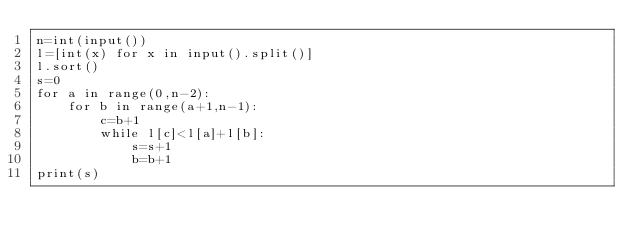Convert code to text. <code><loc_0><loc_0><loc_500><loc_500><_Python_>n=int(input())
l=[int(x) for x in input().split()]
l.sort()
s=0
for a in range(0,n-2):
    for b in range(a+1,n-1):
        c=b+1
        while l[c]<l[a]+l[b]:
            s=s+1
            b=b+1
print(s)</code> 